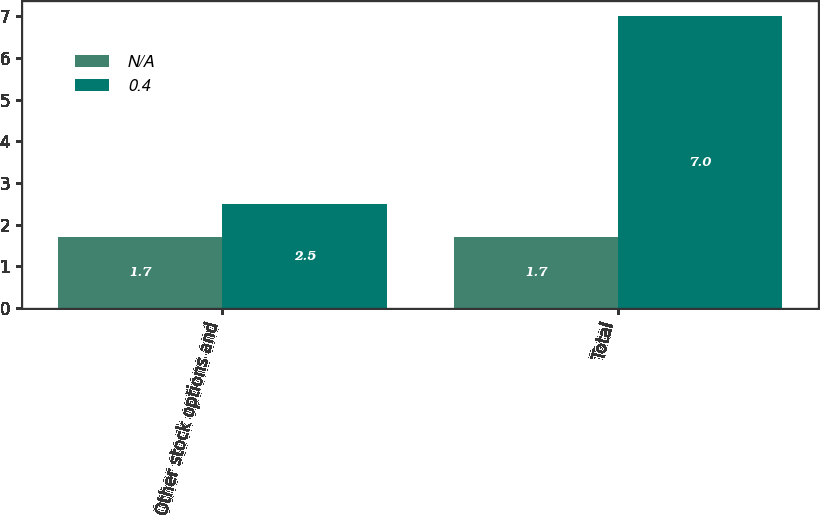<chart> <loc_0><loc_0><loc_500><loc_500><stacked_bar_chart><ecel><fcel>Other stock options and<fcel>Total<nl><fcel>nan<fcel>1.7<fcel>1.7<nl><fcel>0.4<fcel>2.5<fcel>7<nl></chart> 